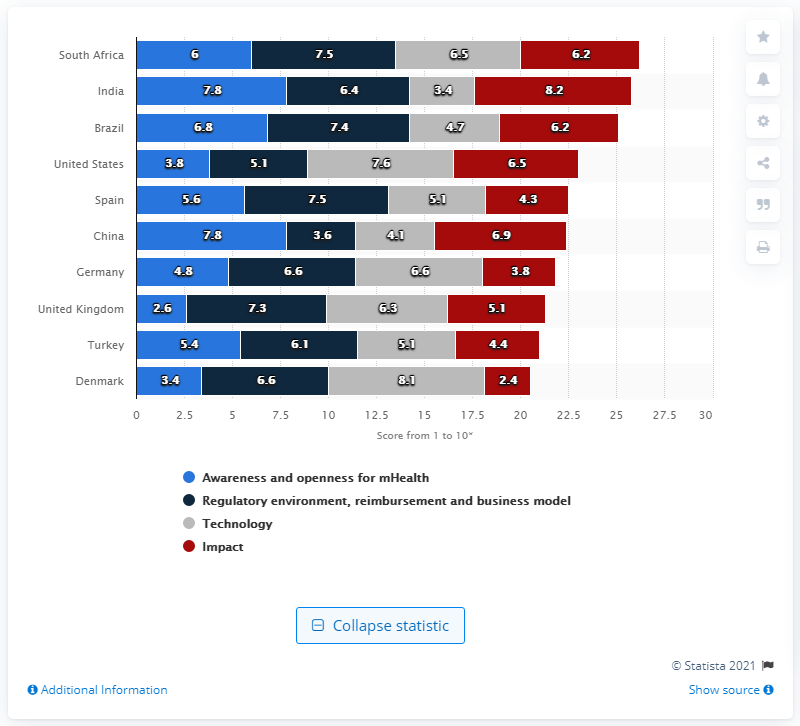Indicate a few pertinent items in this graphic. In 2012, South Africa's awareness and openness towards mHealth was 6 out of 10. 